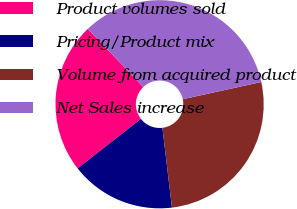<chart> <loc_0><loc_0><loc_500><loc_500><pie_chart><fcel>Product volumes sold<fcel>Pricing/Product mix<fcel>Volume from acquired product<fcel>Net Sales increase<nl><fcel>23.47%<fcel>16.33%<fcel>26.53%<fcel>33.67%<nl></chart> 